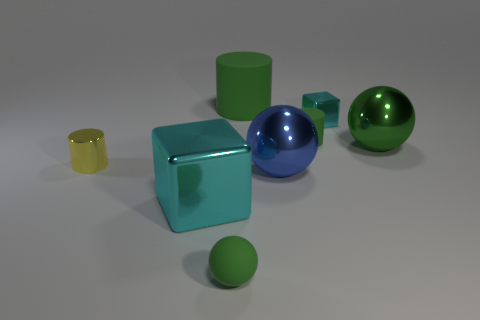There is a matte cylinder that is the same color as the big rubber object; what is its size?
Offer a terse response. Small. What is the material of the big cylinder that is the same color as the rubber sphere?
Ensure brevity in your answer.  Rubber. There is a cyan block to the left of the large rubber cylinder; how big is it?
Your answer should be compact. Large. Are there any big cylinders made of the same material as the tiny cube?
Ensure brevity in your answer.  No. How many tiny cyan things have the same shape as the yellow shiny object?
Your answer should be compact. 0. What is the shape of the small thing in front of the big shiny ball in front of the cylinder that is in front of the small green matte cylinder?
Keep it short and to the point. Sphere. What is the material of the large object that is in front of the tiny cyan metal block and behind the small yellow cylinder?
Make the answer very short. Metal. Is the size of the cyan shiny cube that is to the right of the matte sphere the same as the matte sphere?
Give a very brief answer. Yes. Is there any other thing that is the same size as the metallic cylinder?
Your answer should be very brief. Yes. Are there more green matte cylinders that are in front of the big green matte object than big cyan metallic cubes that are behind the green shiny sphere?
Keep it short and to the point. Yes. 